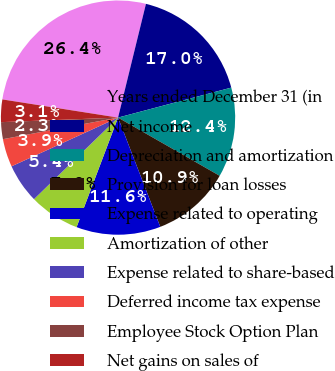Convert chart. <chart><loc_0><loc_0><loc_500><loc_500><pie_chart><fcel>Years ended December 31 (in<fcel>Net income<fcel>Depreciation and amortization<fcel>Provision for loan losses<fcel>Expense related to operating<fcel>Amortization of other<fcel>Expense related to share-based<fcel>Deferred income tax expense<fcel>Employee Stock Option Plan<fcel>Net gains on sales of<nl><fcel>26.35%<fcel>17.05%<fcel>12.4%<fcel>10.85%<fcel>11.63%<fcel>6.98%<fcel>5.43%<fcel>3.88%<fcel>2.33%<fcel>3.1%<nl></chart> 